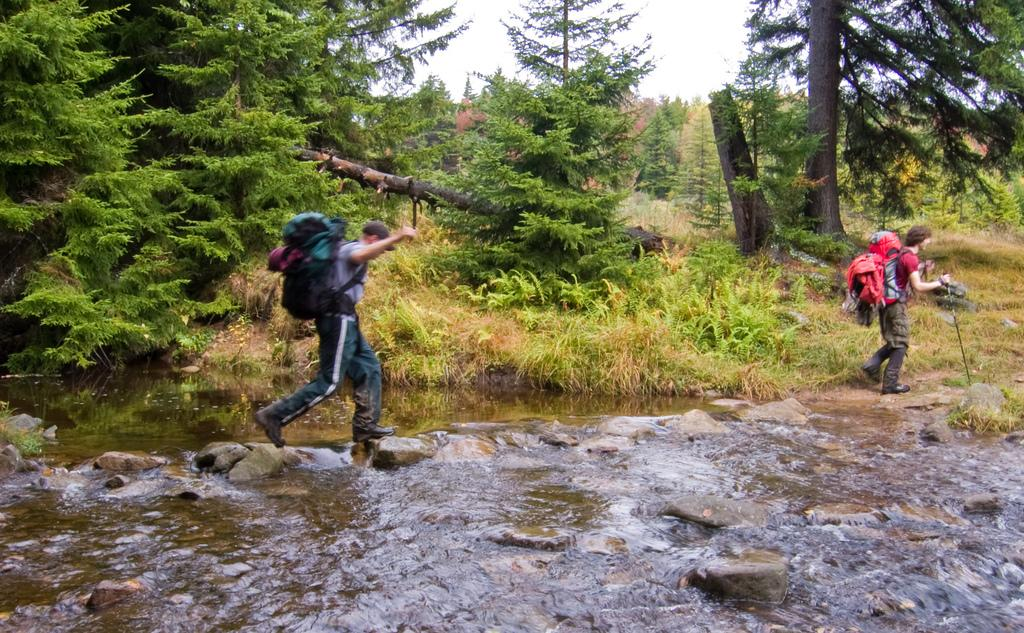What is the primary element visible in the image? There is water in the image. What can be seen within the water? There are rocks in the water. How many people are present in the image? There are two persons standing in the image. What are the persons wearing? The persons are wearing bags. What can be seen in the background of the image? There are trees and the sky visible in the background. What type of book is the person reading in the image? There is no book present in the image; the persons are wearing bags. How many geese are visible in the image? There are no geese present in the image. 